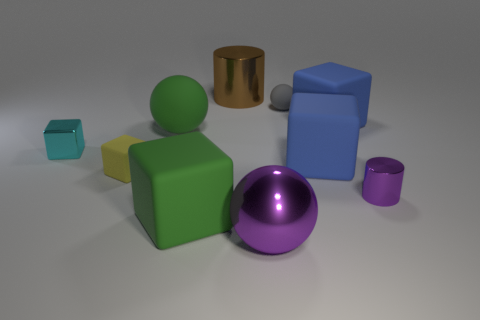How many yellow cubes are the same size as the cyan shiny block?
Provide a succinct answer. 1. Are there fewer cyan things that are behind the gray thing than small gray matte cubes?
Offer a terse response. No. There is a tiny rubber block; what number of small matte objects are on the right side of it?
Provide a succinct answer. 1. There is a rubber sphere that is in front of the small rubber thing that is to the right of the purple thing left of the tiny cylinder; what is its size?
Offer a terse response. Large. Do the tiny cyan thing and the large metal object on the left side of the large purple ball have the same shape?
Provide a succinct answer. No. The other ball that is made of the same material as the green sphere is what size?
Your answer should be very brief. Small. Are there any other things that have the same color as the metallic block?
Your response must be concise. No. What material is the brown cylinder right of the green object behind the tiny matte object that is left of the big shiny cylinder?
Ensure brevity in your answer.  Metal. What number of matte things are either cylinders or big blue blocks?
Offer a terse response. 2. Is the color of the large cylinder the same as the tiny shiny cylinder?
Your answer should be very brief. No. 